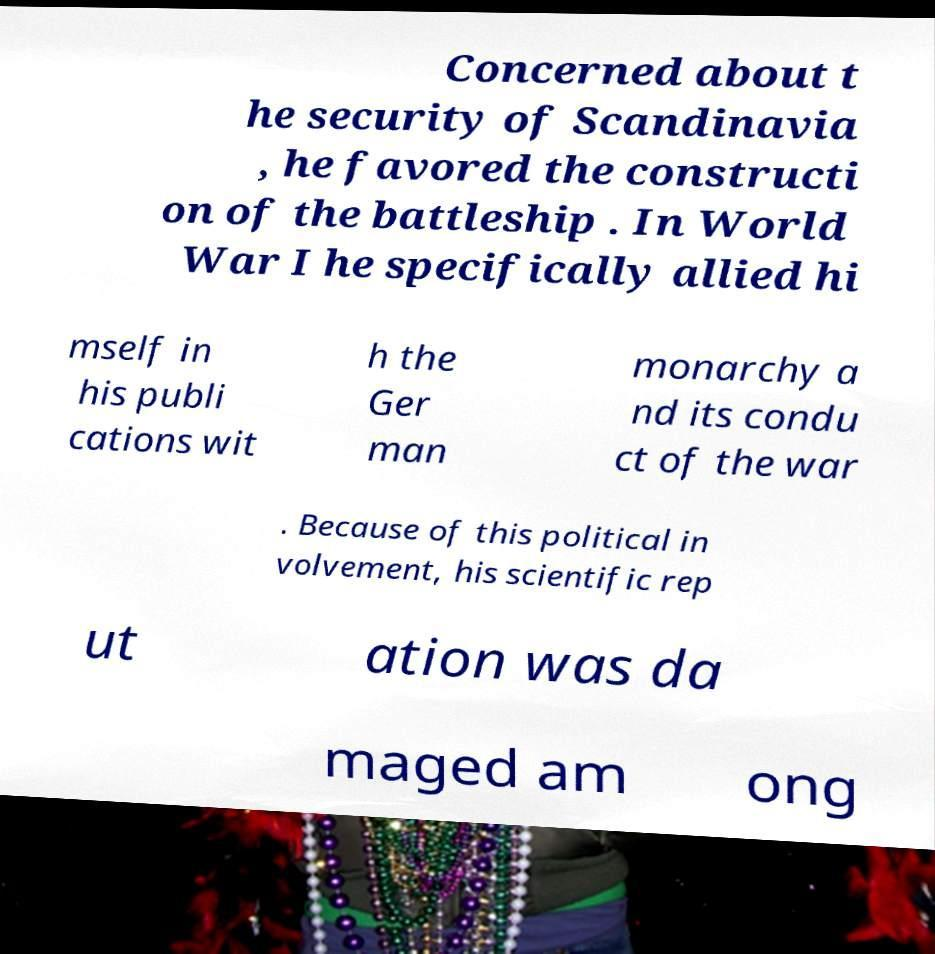Could you extract and type out the text from this image? Concerned about t he security of Scandinavia , he favored the constructi on of the battleship . In World War I he specifically allied hi mself in his publi cations wit h the Ger man monarchy a nd its condu ct of the war . Because of this political in volvement, his scientific rep ut ation was da maged am ong 